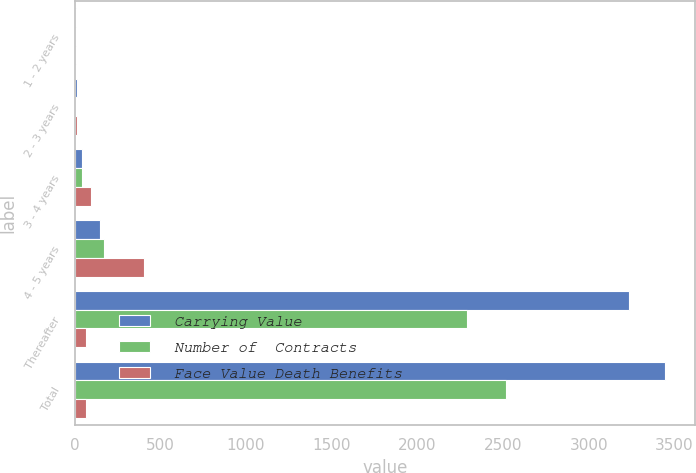Convert chart to OTSL. <chart><loc_0><loc_0><loc_500><loc_500><stacked_bar_chart><ecel><fcel>1 - 2 years<fcel>2 - 3 years<fcel>3 - 4 years<fcel>4 - 5 years<fcel>Thereafter<fcel>Total<nl><fcel>Carrying Value<fcel>5<fcel>16<fcel>43<fcel>148<fcel>3235<fcel>3448<nl><fcel>Number of  Contracts<fcel>5<fcel>6<fcel>43<fcel>171<fcel>2291<fcel>2516<nl><fcel>Face Value Death Benefits<fcel>10<fcel>14<fcel>93<fcel>404<fcel>68<fcel>68<nl></chart> 